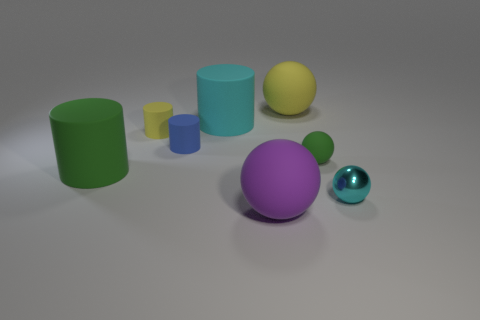Add 2 cyan metallic objects. How many objects exist? 10 Add 2 purple things. How many purple things are left? 3 Add 3 big purple rubber things. How many big purple rubber things exist? 4 Subtract 0 cyan blocks. How many objects are left? 8 Subtract all big green rubber cylinders. Subtract all tiny yellow metal blocks. How many objects are left? 7 